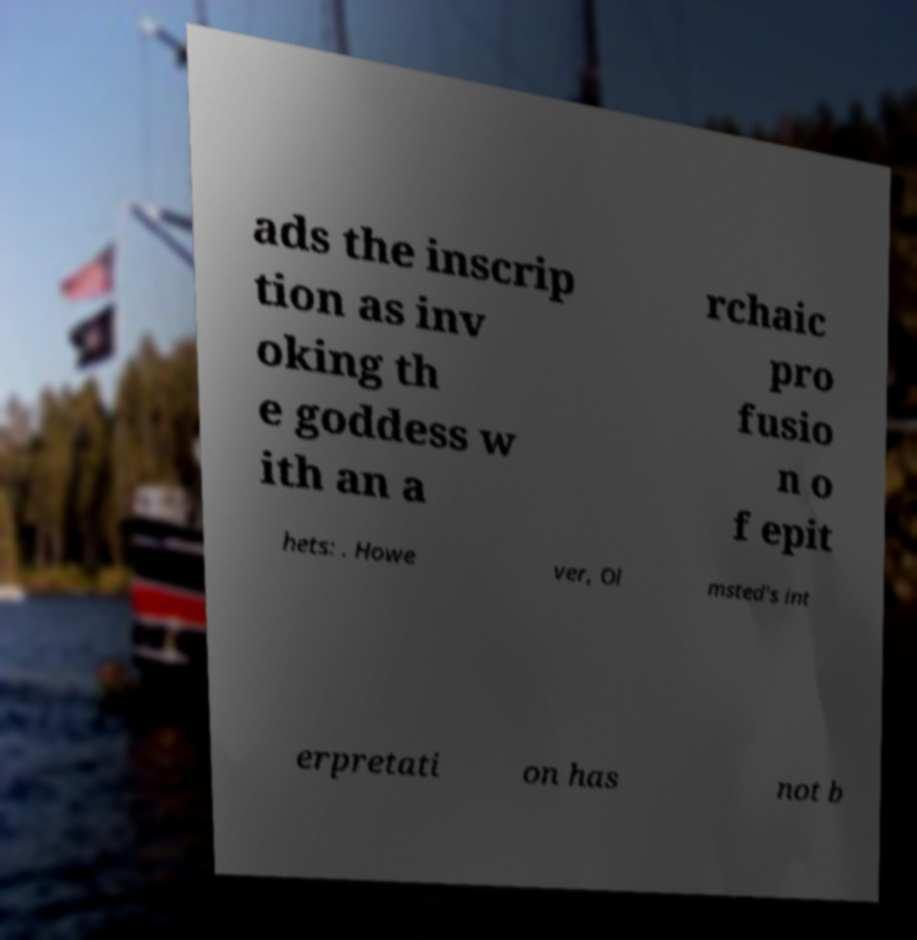Please identify and transcribe the text found in this image. ads the inscrip tion as inv oking th e goddess w ith an a rchaic pro fusio n o f epit hets: . Howe ver, Ol msted's int erpretati on has not b 